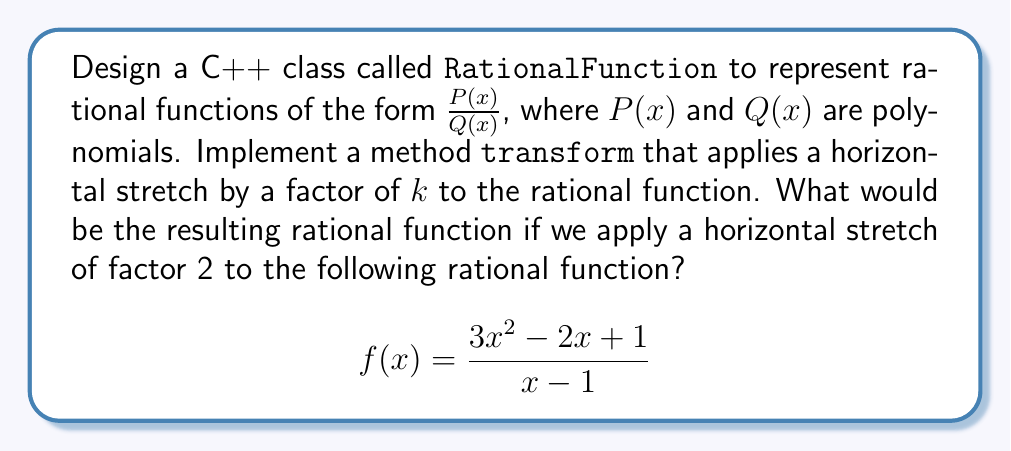Provide a solution to this math problem. To solve this problem, we need to understand how a horizontal stretch affects a rational function and then apply it to the given function. Here's a step-by-step explanation:

1. A horizontal stretch by a factor of $k$ transforms a function $f(x)$ into $f(\frac{x}{k})$.

2. For our given rational function:
   $$f(x) = \frac{3x^2 - 2x + 1}{x - 1}$$

3. We need to apply a horizontal stretch with $k = 2$, so we replace every $x$ with $\frac{x}{2}$:
   $$f(\frac{x}{2}) = \frac{3(\frac{x}{2})^2 - 2(\frac{x}{2}) + 1}{(\frac{x}{2}) - 1}$$

4. Simplify the numerator:
   $3(\frac{x}{2})^2 = 3 \cdot \frac{x^2}{4} = \frac{3x^2}{4}$
   $-2(\frac{x}{2}) = -\frac{x}{1}$
   So, the numerator becomes: $\frac{3x^2}{4} - x + 1$

5. Simplify the denominator:
   $\frac{x}{2} - 1 = \frac{x - 2}{2}$

6. Combining the simplified numerator and denominator:
   $$f(\frac{x}{2}) = \frac{\frac{3x^2}{4} - x + 1}{\frac{x - 2}{2}}$$

7. To eliminate fractions in the numerator and denominator, multiply both by 4:
   $$f(\frac{x}{2}) = \frac{3x^2 - 4x + 4}{2x - 4}$$

This is the resulting rational function after applying a horizontal stretch by a factor of 2.
Answer: $\frac{3x^2 - 4x + 4}{2x - 4}$ 